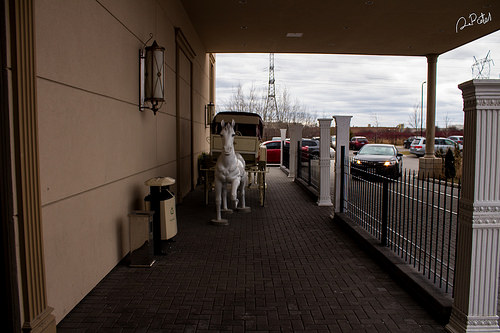<image>
Can you confirm if the car is behind the horse? Yes. From this viewpoint, the car is positioned behind the horse, with the horse partially or fully occluding the car. 